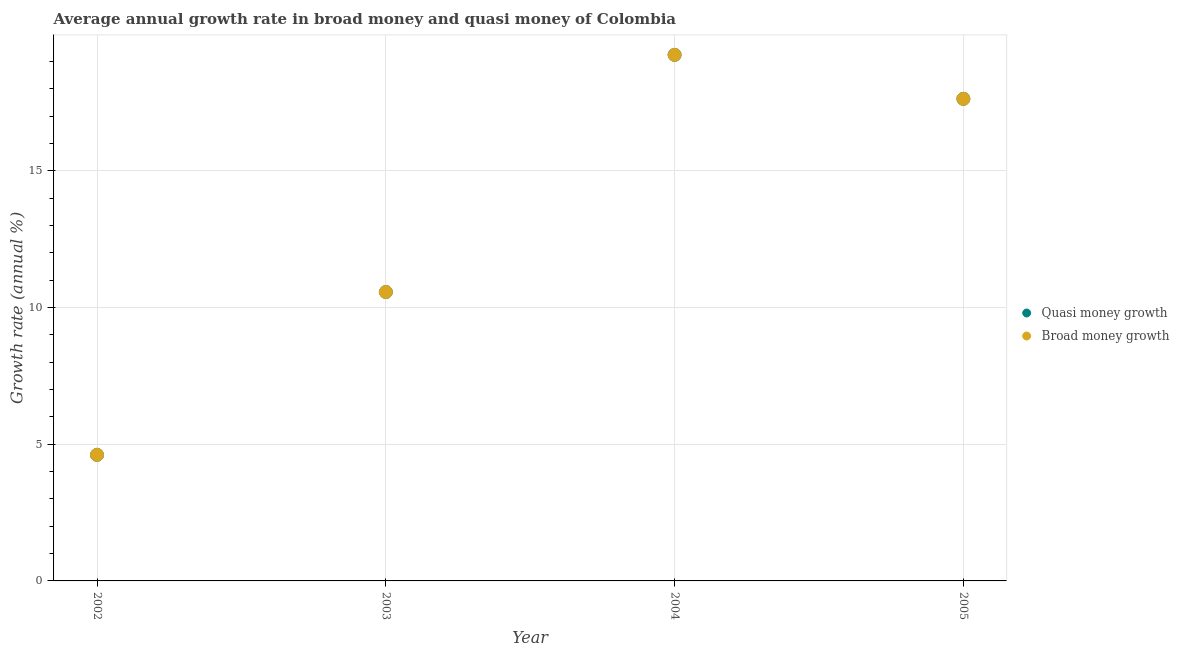How many different coloured dotlines are there?
Keep it short and to the point. 2. Is the number of dotlines equal to the number of legend labels?
Your response must be concise. Yes. What is the annual growth rate in broad money in 2004?
Make the answer very short. 19.24. Across all years, what is the maximum annual growth rate in broad money?
Give a very brief answer. 19.24. Across all years, what is the minimum annual growth rate in broad money?
Keep it short and to the point. 4.61. In which year was the annual growth rate in broad money minimum?
Offer a very short reply. 2002. What is the total annual growth rate in broad money in the graph?
Offer a very short reply. 52.05. What is the difference between the annual growth rate in broad money in 2002 and that in 2005?
Your answer should be very brief. -13.02. What is the difference between the annual growth rate in broad money in 2002 and the annual growth rate in quasi money in 2004?
Keep it short and to the point. -14.63. What is the average annual growth rate in quasi money per year?
Offer a very short reply. 13.01. In how many years, is the annual growth rate in broad money greater than 2 %?
Your answer should be very brief. 4. What is the ratio of the annual growth rate in quasi money in 2002 to that in 2003?
Make the answer very short. 0.44. What is the difference between the highest and the second highest annual growth rate in quasi money?
Provide a succinct answer. 1.61. What is the difference between the highest and the lowest annual growth rate in broad money?
Your answer should be very brief. 14.63. Is the annual growth rate in broad money strictly less than the annual growth rate in quasi money over the years?
Your response must be concise. No. How many dotlines are there?
Provide a short and direct response. 2. Where does the legend appear in the graph?
Keep it short and to the point. Center right. What is the title of the graph?
Give a very brief answer. Average annual growth rate in broad money and quasi money of Colombia. What is the label or title of the Y-axis?
Ensure brevity in your answer.  Growth rate (annual %). What is the Growth rate (annual %) in Quasi money growth in 2002?
Offer a very short reply. 4.61. What is the Growth rate (annual %) of Broad money growth in 2002?
Your answer should be very brief. 4.61. What is the Growth rate (annual %) of Quasi money growth in 2003?
Provide a succinct answer. 10.57. What is the Growth rate (annual %) in Broad money growth in 2003?
Provide a succinct answer. 10.57. What is the Growth rate (annual %) of Quasi money growth in 2004?
Your answer should be compact. 19.24. What is the Growth rate (annual %) of Broad money growth in 2004?
Give a very brief answer. 19.24. What is the Growth rate (annual %) of Quasi money growth in 2005?
Make the answer very short. 17.63. What is the Growth rate (annual %) in Broad money growth in 2005?
Offer a very short reply. 17.63. Across all years, what is the maximum Growth rate (annual %) of Quasi money growth?
Your answer should be very brief. 19.24. Across all years, what is the maximum Growth rate (annual %) of Broad money growth?
Make the answer very short. 19.24. Across all years, what is the minimum Growth rate (annual %) of Quasi money growth?
Offer a terse response. 4.61. Across all years, what is the minimum Growth rate (annual %) of Broad money growth?
Keep it short and to the point. 4.61. What is the total Growth rate (annual %) in Quasi money growth in the graph?
Your answer should be very brief. 52.05. What is the total Growth rate (annual %) of Broad money growth in the graph?
Provide a succinct answer. 52.05. What is the difference between the Growth rate (annual %) in Quasi money growth in 2002 and that in 2003?
Ensure brevity in your answer.  -5.95. What is the difference between the Growth rate (annual %) of Broad money growth in 2002 and that in 2003?
Your response must be concise. -5.95. What is the difference between the Growth rate (annual %) of Quasi money growth in 2002 and that in 2004?
Your answer should be very brief. -14.63. What is the difference between the Growth rate (annual %) in Broad money growth in 2002 and that in 2004?
Offer a very short reply. -14.63. What is the difference between the Growth rate (annual %) in Quasi money growth in 2002 and that in 2005?
Your answer should be very brief. -13.02. What is the difference between the Growth rate (annual %) of Broad money growth in 2002 and that in 2005?
Ensure brevity in your answer.  -13.02. What is the difference between the Growth rate (annual %) in Quasi money growth in 2003 and that in 2004?
Your answer should be compact. -8.67. What is the difference between the Growth rate (annual %) of Broad money growth in 2003 and that in 2004?
Provide a short and direct response. -8.67. What is the difference between the Growth rate (annual %) of Quasi money growth in 2003 and that in 2005?
Provide a succinct answer. -7.07. What is the difference between the Growth rate (annual %) of Broad money growth in 2003 and that in 2005?
Give a very brief answer. -7.07. What is the difference between the Growth rate (annual %) in Quasi money growth in 2004 and that in 2005?
Make the answer very short. 1.61. What is the difference between the Growth rate (annual %) in Broad money growth in 2004 and that in 2005?
Offer a terse response. 1.61. What is the difference between the Growth rate (annual %) in Quasi money growth in 2002 and the Growth rate (annual %) in Broad money growth in 2003?
Your answer should be compact. -5.95. What is the difference between the Growth rate (annual %) of Quasi money growth in 2002 and the Growth rate (annual %) of Broad money growth in 2004?
Make the answer very short. -14.63. What is the difference between the Growth rate (annual %) of Quasi money growth in 2002 and the Growth rate (annual %) of Broad money growth in 2005?
Keep it short and to the point. -13.02. What is the difference between the Growth rate (annual %) of Quasi money growth in 2003 and the Growth rate (annual %) of Broad money growth in 2004?
Your answer should be very brief. -8.67. What is the difference between the Growth rate (annual %) in Quasi money growth in 2003 and the Growth rate (annual %) in Broad money growth in 2005?
Make the answer very short. -7.07. What is the difference between the Growth rate (annual %) of Quasi money growth in 2004 and the Growth rate (annual %) of Broad money growth in 2005?
Provide a short and direct response. 1.61. What is the average Growth rate (annual %) in Quasi money growth per year?
Ensure brevity in your answer.  13.01. What is the average Growth rate (annual %) of Broad money growth per year?
Ensure brevity in your answer.  13.01. In the year 2002, what is the difference between the Growth rate (annual %) of Quasi money growth and Growth rate (annual %) of Broad money growth?
Your answer should be compact. 0. In the year 2005, what is the difference between the Growth rate (annual %) of Quasi money growth and Growth rate (annual %) of Broad money growth?
Offer a very short reply. 0. What is the ratio of the Growth rate (annual %) in Quasi money growth in 2002 to that in 2003?
Offer a terse response. 0.44. What is the ratio of the Growth rate (annual %) of Broad money growth in 2002 to that in 2003?
Your answer should be very brief. 0.44. What is the ratio of the Growth rate (annual %) in Quasi money growth in 2002 to that in 2004?
Your response must be concise. 0.24. What is the ratio of the Growth rate (annual %) in Broad money growth in 2002 to that in 2004?
Your answer should be very brief. 0.24. What is the ratio of the Growth rate (annual %) of Quasi money growth in 2002 to that in 2005?
Offer a very short reply. 0.26. What is the ratio of the Growth rate (annual %) of Broad money growth in 2002 to that in 2005?
Make the answer very short. 0.26. What is the ratio of the Growth rate (annual %) in Quasi money growth in 2003 to that in 2004?
Your answer should be very brief. 0.55. What is the ratio of the Growth rate (annual %) of Broad money growth in 2003 to that in 2004?
Keep it short and to the point. 0.55. What is the ratio of the Growth rate (annual %) in Quasi money growth in 2003 to that in 2005?
Provide a short and direct response. 0.6. What is the ratio of the Growth rate (annual %) in Broad money growth in 2003 to that in 2005?
Ensure brevity in your answer.  0.6. What is the ratio of the Growth rate (annual %) of Quasi money growth in 2004 to that in 2005?
Provide a succinct answer. 1.09. What is the ratio of the Growth rate (annual %) in Broad money growth in 2004 to that in 2005?
Offer a very short reply. 1.09. What is the difference between the highest and the second highest Growth rate (annual %) in Quasi money growth?
Make the answer very short. 1.61. What is the difference between the highest and the second highest Growth rate (annual %) of Broad money growth?
Your response must be concise. 1.61. What is the difference between the highest and the lowest Growth rate (annual %) of Quasi money growth?
Offer a very short reply. 14.63. What is the difference between the highest and the lowest Growth rate (annual %) in Broad money growth?
Give a very brief answer. 14.63. 